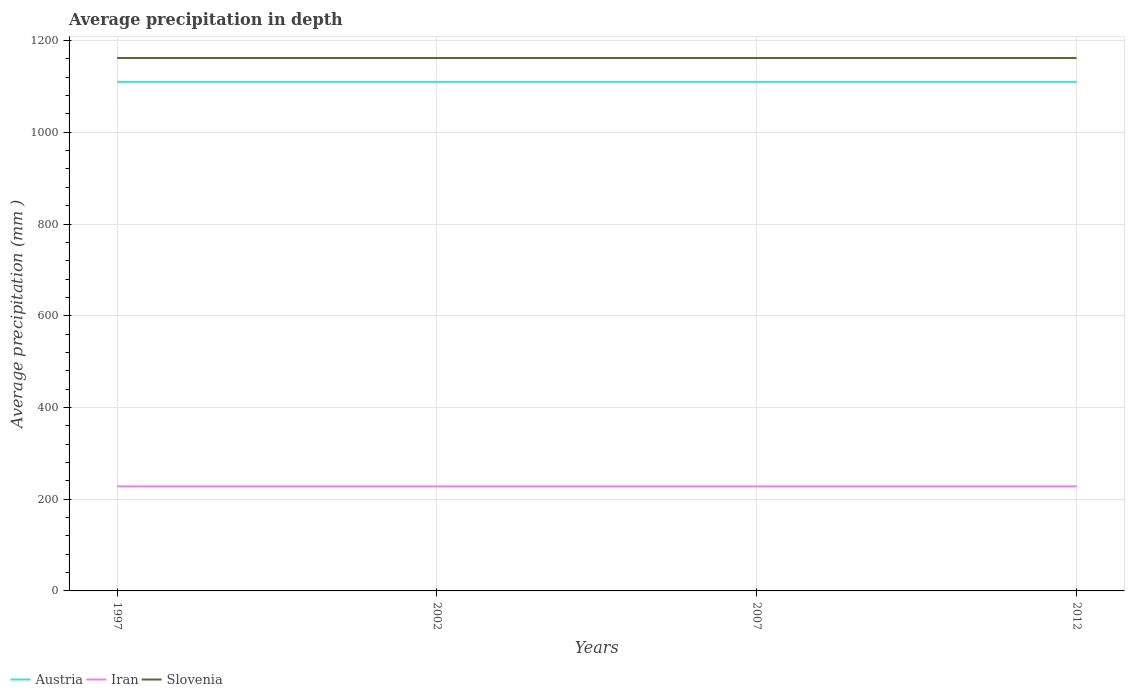How many different coloured lines are there?
Give a very brief answer. 3. Across all years, what is the maximum average precipitation in Iran?
Ensure brevity in your answer.  228. What is the difference between the highest and the second highest average precipitation in Iran?
Make the answer very short. 0. What is the difference between the highest and the lowest average precipitation in Iran?
Your answer should be very brief. 0. How many lines are there?
Keep it short and to the point. 3. How many years are there in the graph?
Offer a terse response. 4. What is the difference between two consecutive major ticks on the Y-axis?
Give a very brief answer. 200. Where does the legend appear in the graph?
Ensure brevity in your answer.  Bottom left. What is the title of the graph?
Your answer should be compact. Average precipitation in depth. What is the label or title of the X-axis?
Make the answer very short. Years. What is the label or title of the Y-axis?
Your answer should be very brief. Average precipitation (mm ). What is the Average precipitation (mm ) in Austria in 1997?
Keep it short and to the point. 1110. What is the Average precipitation (mm ) of Iran in 1997?
Your answer should be compact. 228. What is the Average precipitation (mm ) in Slovenia in 1997?
Provide a succinct answer. 1162. What is the Average precipitation (mm ) of Austria in 2002?
Offer a very short reply. 1110. What is the Average precipitation (mm ) in Iran in 2002?
Ensure brevity in your answer.  228. What is the Average precipitation (mm ) of Slovenia in 2002?
Offer a very short reply. 1162. What is the Average precipitation (mm ) in Austria in 2007?
Keep it short and to the point. 1110. What is the Average precipitation (mm ) in Iran in 2007?
Provide a succinct answer. 228. What is the Average precipitation (mm ) in Slovenia in 2007?
Offer a very short reply. 1162. What is the Average precipitation (mm ) of Austria in 2012?
Give a very brief answer. 1110. What is the Average precipitation (mm ) of Iran in 2012?
Your answer should be compact. 228. What is the Average precipitation (mm ) of Slovenia in 2012?
Offer a very short reply. 1162. Across all years, what is the maximum Average precipitation (mm ) in Austria?
Your response must be concise. 1110. Across all years, what is the maximum Average precipitation (mm ) in Iran?
Provide a succinct answer. 228. Across all years, what is the maximum Average precipitation (mm ) of Slovenia?
Your response must be concise. 1162. Across all years, what is the minimum Average precipitation (mm ) of Austria?
Your answer should be compact. 1110. Across all years, what is the minimum Average precipitation (mm ) of Iran?
Keep it short and to the point. 228. Across all years, what is the minimum Average precipitation (mm ) in Slovenia?
Your response must be concise. 1162. What is the total Average precipitation (mm ) of Austria in the graph?
Keep it short and to the point. 4440. What is the total Average precipitation (mm ) in Iran in the graph?
Provide a succinct answer. 912. What is the total Average precipitation (mm ) in Slovenia in the graph?
Offer a terse response. 4648. What is the difference between the Average precipitation (mm ) in Austria in 1997 and that in 2002?
Ensure brevity in your answer.  0. What is the difference between the Average precipitation (mm ) in Iran in 1997 and that in 2002?
Offer a terse response. 0. What is the difference between the Average precipitation (mm ) in Slovenia in 1997 and that in 2002?
Offer a terse response. 0. What is the difference between the Average precipitation (mm ) in Iran in 1997 and that in 2007?
Give a very brief answer. 0. What is the difference between the Average precipitation (mm ) of Austria in 1997 and that in 2012?
Offer a terse response. 0. What is the difference between the Average precipitation (mm ) in Iran in 1997 and that in 2012?
Make the answer very short. 0. What is the difference between the Average precipitation (mm ) of Slovenia in 1997 and that in 2012?
Make the answer very short. 0. What is the difference between the Average precipitation (mm ) in Iran in 2002 and that in 2012?
Provide a succinct answer. 0. What is the difference between the Average precipitation (mm ) in Slovenia in 2002 and that in 2012?
Provide a succinct answer. 0. What is the difference between the Average precipitation (mm ) of Austria in 2007 and that in 2012?
Your answer should be compact. 0. What is the difference between the Average precipitation (mm ) in Austria in 1997 and the Average precipitation (mm ) in Iran in 2002?
Offer a very short reply. 882. What is the difference between the Average precipitation (mm ) of Austria in 1997 and the Average precipitation (mm ) of Slovenia in 2002?
Your response must be concise. -52. What is the difference between the Average precipitation (mm ) in Iran in 1997 and the Average precipitation (mm ) in Slovenia in 2002?
Keep it short and to the point. -934. What is the difference between the Average precipitation (mm ) of Austria in 1997 and the Average precipitation (mm ) of Iran in 2007?
Your response must be concise. 882. What is the difference between the Average precipitation (mm ) in Austria in 1997 and the Average precipitation (mm ) in Slovenia in 2007?
Your response must be concise. -52. What is the difference between the Average precipitation (mm ) in Iran in 1997 and the Average precipitation (mm ) in Slovenia in 2007?
Ensure brevity in your answer.  -934. What is the difference between the Average precipitation (mm ) in Austria in 1997 and the Average precipitation (mm ) in Iran in 2012?
Keep it short and to the point. 882. What is the difference between the Average precipitation (mm ) in Austria in 1997 and the Average precipitation (mm ) in Slovenia in 2012?
Your response must be concise. -52. What is the difference between the Average precipitation (mm ) of Iran in 1997 and the Average precipitation (mm ) of Slovenia in 2012?
Offer a very short reply. -934. What is the difference between the Average precipitation (mm ) of Austria in 2002 and the Average precipitation (mm ) of Iran in 2007?
Your answer should be very brief. 882. What is the difference between the Average precipitation (mm ) of Austria in 2002 and the Average precipitation (mm ) of Slovenia in 2007?
Your answer should be compact. -52. What is the difference between the Average precipitation (mm ) in Iran in 2002 and the Average precipitation (mm ) in Slovenia in 2007?
Offer a very short reply. -934. What is the difference between the Average precipitation (mm ) of Austria in 2002 and the Average precipitation (mm ) of Iran in 2012?
Provide a succinct answer. 882. What is the difference between the Average precipitation (mm ) of Austria in 2002 and the Average precipitation (mm ) of Slovenia in 2012?
Ensure brevity in your answer.  -52. What is the difference between the Average precipitation (mm ) of Iran in 2002 and the Average precipitation (mm ) of Slovenia in 2012?
Make the answer very short. -934. What is the difference between the Average precipitation (mm ) of Austria in 2007 and the Average precipitation (mm ) of Iran in 2012?
Make the answer very short. 882. What is the difference between the Average precipitation (mm ) in Austria in 2007 and the Average precipitation (mm ) in Slovenia in 2012?
Your response must be concise. -52. What is the difference between the Average precipitation (mm ) in Iran in 2007 and the Average precipitation (mm ) in Slovenia in 2012?
Make the answer very short. -934. What is the average Average precipitation (mm ) of Austria per year?
Ensure brevity in your answer.  1110. What is the average Average precipitation (mm ) in Iran per year?
Provide a succinct answer. 228. What is the average Average precipitation (mm ) of Slovenia per year?
Give a very brief answer. 1162. In the year 1997, what is the difference between the Average precipitation (mm ) of Austria and Average precipitation (mm ) of Iran?
Keep it short and to the point. 882. In the year 1997, what is the difference between the Average precipitation (mm ) of Austria and Average precipitation (mm ) of Slovenia?
Provide a succinct answer. -52. In the year 1997, what is the difference between the Average precipitation (mm ) in Iran and Average precipitation (mm ) in Slovenia?
Make the answer very short. -934. In the year 2002, what is the difference between the Average precipitation (mm ) of Austria and Average precipitation (mm ) of Iran?
Ensure brevity in your answer.  882. In the year 2002, what is the difference between the Average precipitation (mm ) in Austria and Average precipitation (mm ) in Slovenia?
Keep it short and to the point. -52. In the year 2002, what is the difference between the Average precipitation (mm ) in Iran and Average precipitation (mm ) in Slovenia?
Ensure brevity in your answer.  -934. In the year 2007, what is the difference between the Average precipitation (mm ) in Austria and Average precipitation (mm ) in Iran?
Your answer should be very brief. 882. In the year 2007, what is the difference between the Average precipitation (mm ) of Austria and Average precipitation (mm ) of Slovenia?
Your response must be concise. -52. In the year 2007, what is the difference between the Average precipitation (mm ) in Iran and Average precipitation (mm ) in Slovenia?
Make the answer very short. -934. In the year 2012, what is the difference between the Average precipitation (mm ) of Austria and Average precipitation (mm ) of Iran?
Keep it short and to the point. 882. In the year 2012, what is the difference between the Average precipitation (mm ) in Austria and Average precipitation (mm ) in Slovenia?
Your response must be concise. -52. In the year 2012, what is the difference between the Average precipitation (mm ) of Iran and Average precipitation (mm ) of Slovenia?
Make the answer very short. -934. What is the ratio of the Average precipitation (mm ) of Austria in 1997 to that in 2002?
Ensure brevity in your answer.  1. What is the ratio of the Average precipitation (mm ) in Iran in 1997 to that in 2002?
Ensure brevity in your answer.  1. What is the ratio of the Average precipitation (mm ) of Slovenia in 1997 to that in 2007?
Provide a succinct answer. 1. What is the ratio of the Average precipitation (mm ) in Austria in 1997 to that in 2012?
Your answer should be very brief. 1. What is the ratio of the Average precipitation (mm ) of Iran in 1997 to that in 2012?
Ensure brevity in your answer.  1. What is the ratio of the Average precipitation (mm ) in Slovenia in 1997 to that in 2012?
Provide a succinct answer. 1. What is the ratio of the Average precipitation (mm ) in Slovenia in 2002 to that in 2007?
Offer a terse response. 1. What is the ratio of the Average precipitation (mm ) of Iran in 2002 to that in 2012?
Your answer should be compact. 1. What is the ratio of the Average precipitation (mm ) in Austria in 2007 to that in 2012?
Offer a terse response. 1. What is the difference between the highest and the second highest Average precipitation (mm ) of Austria?
Offer a very short reply. 0. What is the difference between the highest and the second highest Average precipitation (mm ) in Slovenia?
Provide a short and direct response. 0. What is the difference between the highest and the lowest Average precipitation (mm ) in Austria?
Offer a terse response. 0. What is the difference between the highest and the lowest Average precipitation (mm ) in Iran?
Keep it short and to the point. 0. 